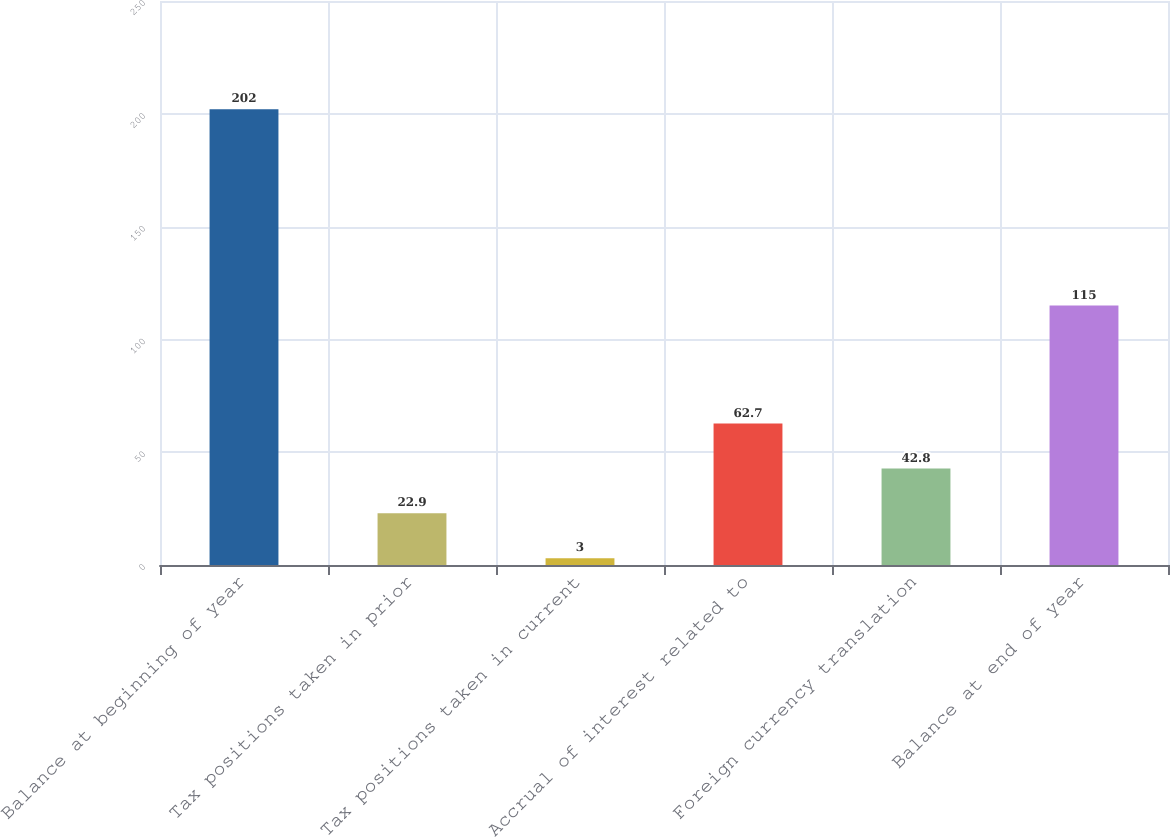Convert chart to OTSL. <chart><loc_0><loc_0><loc_500><loc_500><bar_chart><fcel>Balance at beginning of year<fcel>Tax positions taken in prior<fcel>Tax positions taken in current<fcel>Accrual of interest related to<fcel>Foreign currency translation<fcel>Balance at end of year<nl><fcel>202<fcel>22.9<fcel>3<fcel>62.7<fcel>42.8<fcel>115<nl></chart> 